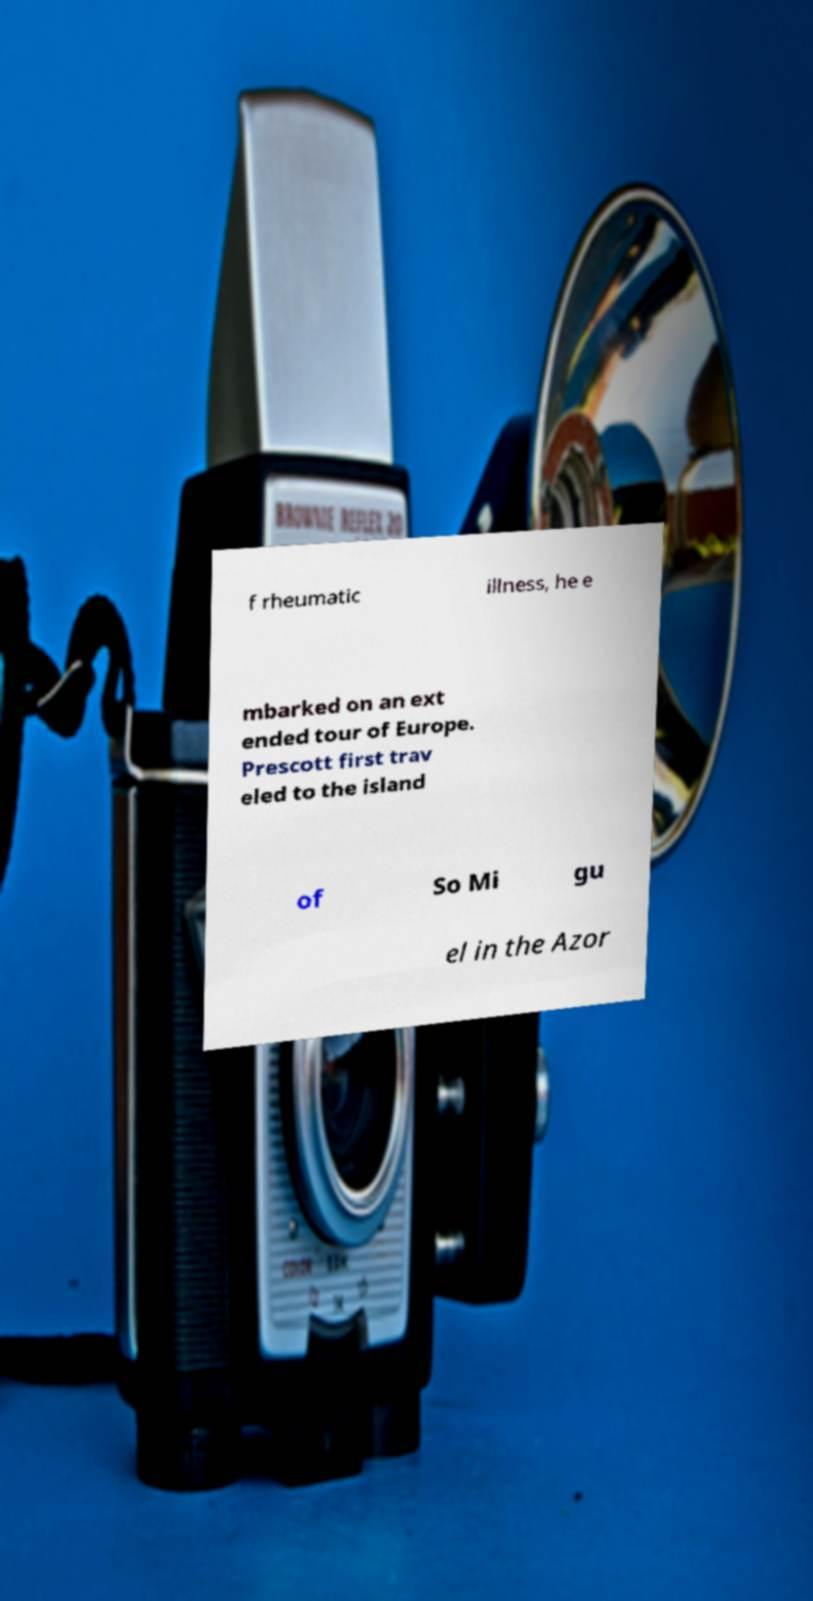Could you extract and type out the text from this image? f rheumatic illness, he e mbarked on an ext ended tour of Europe. Prescott first trav eled to the island of So Mi gu el in the Azor 